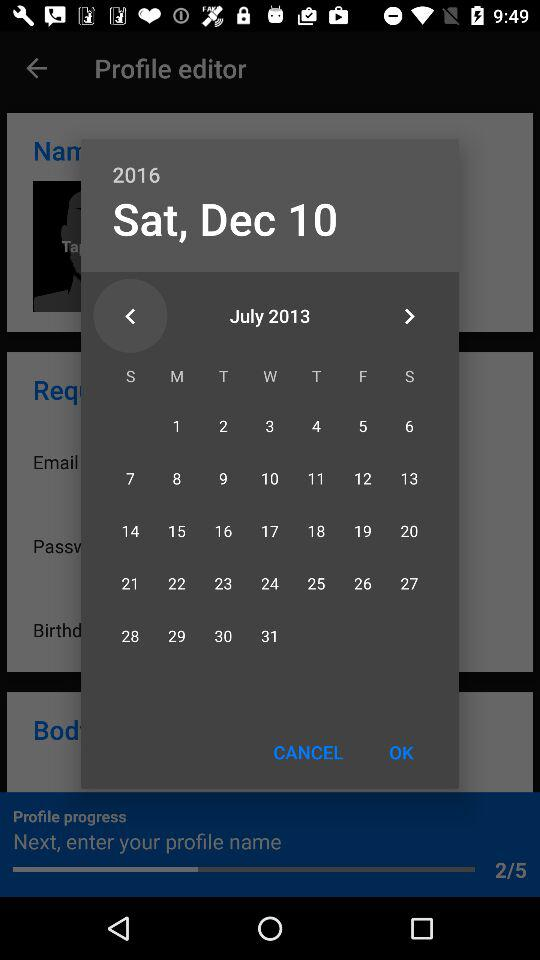What is the selected date? The selected date is Saturday, December 10, 2016. 